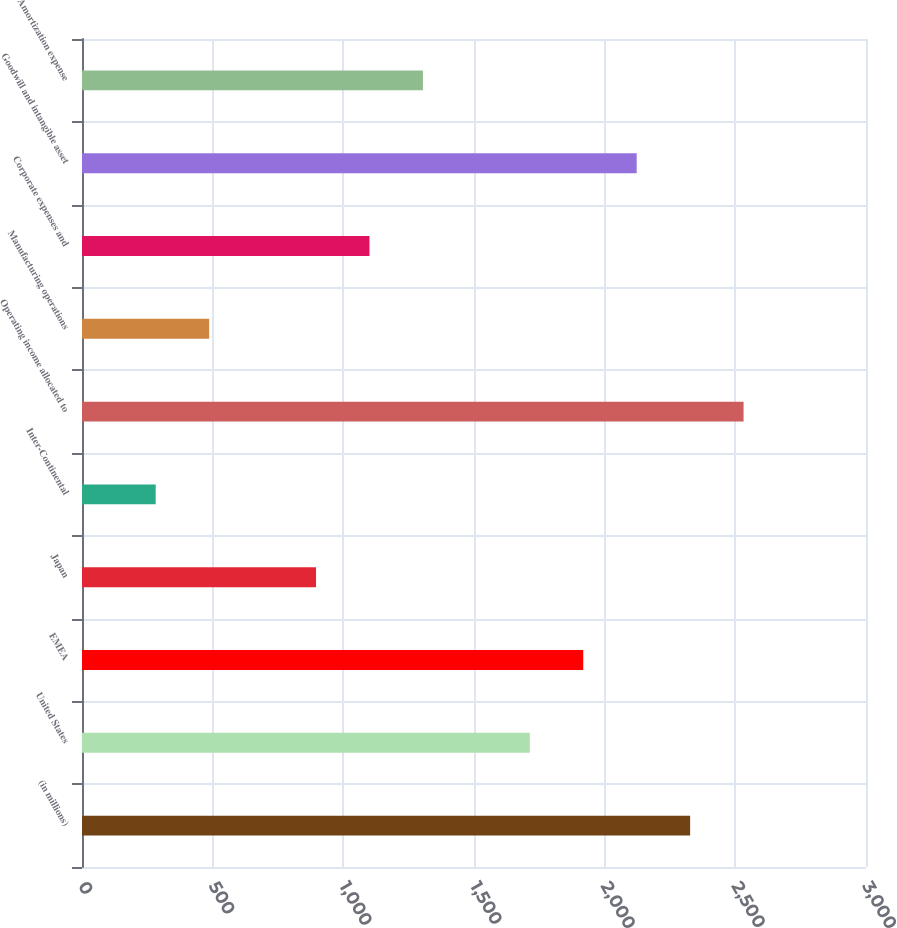<chart> <loc_0><loc_0><loc_500><loc_500><bar_chart><fcel>(in millions)<fcel>United States<fcel>EMEA<fcel>Japan<fcel>Inter-Continental<fcel>Operating income allocated to<fcel>Manufacturing operations<fcel>Corporate expenses and<fcel>Goodwill and intangible asset<fcel>Amortization expense<nl><fcel>2327<fcel>1713.5<fcel>1918<fcel>895.5<fcel>282<fcel>2531.5<fcel>486.5<fcel>1100<fcel>2122.5<fcel>1304.5<nl></chart> 